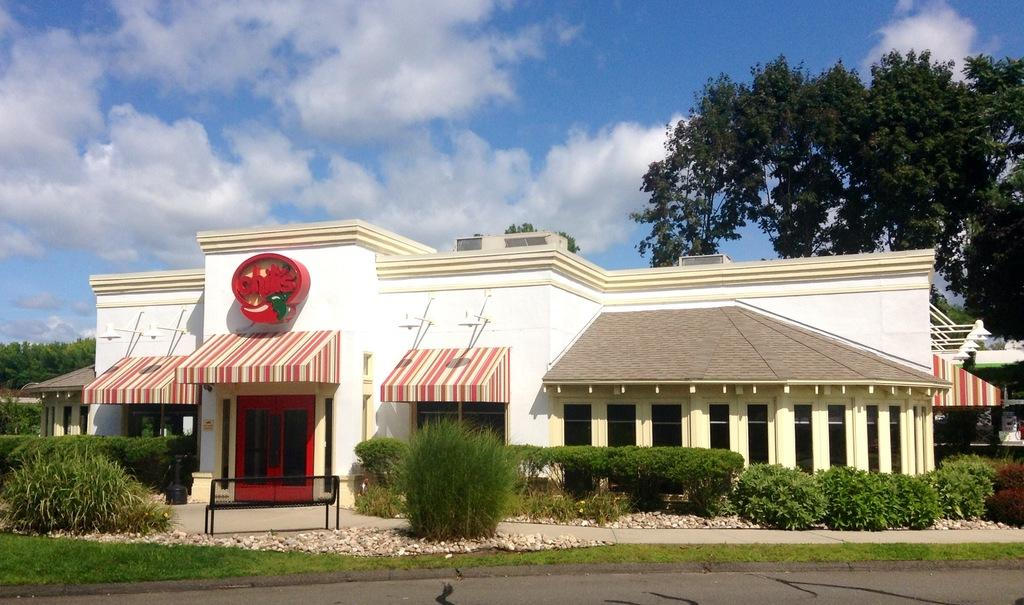<image>
Summarize the visual content of the image. Green plants around the entrance to a Chili's restaurant. 